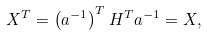<formula> <loc_0><loc_0><loc_500><loc_500>X ^ { T } = \left ( a ^ { - 1 } \right ) ^ { T } H ^ { T } a ^ { - 1 } = X ,</formula> 